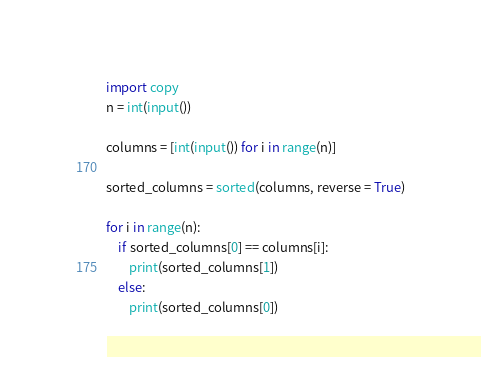<code> <loc_0><loc_0><loc_500><loc_500><_Python_>import copy
n = int(input())
 
columns = [int(input()) for i in range(n)]

sorted_columns = sorted(columns, reverse = True)

for i in range(n):
    if sorted_columns[0] == columns[i]:
        print(sorted_columns[1])
    else:
        print(sorted_columns[0])</code> 